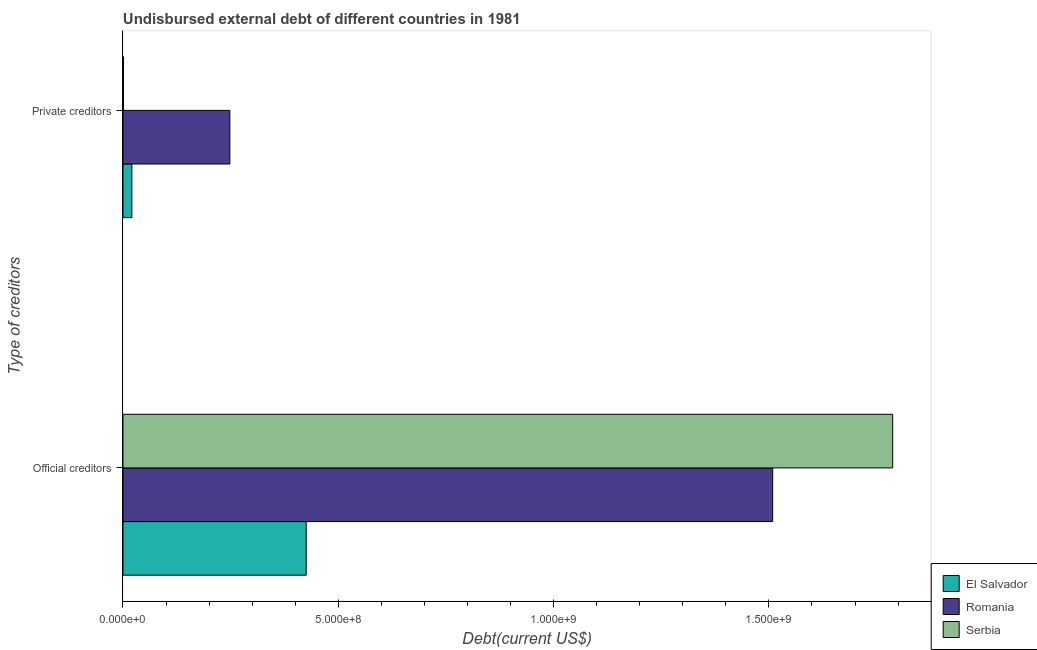How many different coloured bars are there?
Your response must be concise. 3. Are the number of bars on each tick of the Y-axis equal?
Give a very brief answer. Yes. How many bars are there on the 2nd tick from the bottom?
Keep it short and to the point. 3. What is the label of the 1st group of bars from the top?
Offer a very short reply. Private creditors. What is the undisbursed external debt of private creditors in El Salvador?
Your answer should be very brief. 2.06e+07. Across all countries, what is the maximum undisbursed external debt of official creditors?
Provide a short and direct response. 1.79e+09. Across all countries, what is the minimum undisbursed external debt of official creditors?
Keep it short and to the point. 4.26e+08. In which country was the undisbursed external debt of private creditors maximum?
Ensure brevity in your answer.  Romania. In which country was the undisbursed external debt of official creditors minimum?
Your answer should be very brief. El Salvador. What is the total undisbursed external debt of private creditors in the graph?
Provide a short and direct response. 2.70e+08. What is the difference between the undisbursed external debt of official creditors in Serbia and that in El Salvador?
Keep it short and to the point. 1.36e+09. What is the difference between the undisbursed external debt of official creditors in Romania and the undisbursed external debt of private creditors in El Salvador?
Your answer should be compact. 1.49e+09. What is the average undisbursed external debt of official creditors per country?
Your answer should be very brief. 1.24e+09. What is the difference between the undisbursed external debt of private creditors and undisbursed external debt of official creditors in Serbia?
Provide a succinct answer. -1.79e+09. What is the ratio of the undisbursed external debt of private creditors in Serbia to that in El Salvador?
Provide a short and direct response. 0.06. What does the 3rd bar from the top in Official creditors represents?
Give a very brief answer. El Salvador. What does the 2nd bar from the bottom in Private creditors represents?
Make the answer very short. Romania. How many bars are there?
Offer a terse response. 6. Are all the bars in the graph horizontal?
Provide a succinct answer. Yes. How many countries are there in the graph?
Provide a succinct answer. 3. Does the graph contain any zero values?
Your response must be concise. No. How many legend labels are there?
Your answer should be compact. 3. What is the title of the graph?
Your response must be concise. Undisbursed external debt of different countries in 1981. Does "Euro area" appear as one of the legend labels in the graph?
Give a very brief answer. No. What is the label or title of the X-axis?
Your answer should be very brief. Debt(current US$). What is the label or title of the Y-axis?
Give a very brief answer. Type of creditors. What is the Debt(current US$) of El Salvador in Official creditors?
Provide a short and direct response. 4.26e+08. What is the Debt(current US$) in Romania in Official creditors?
Ensure brevity in your answer.  1.51e+09. What is the Debt(current US$) of Serbia in Official creditors?
Give a very brief answer. 1.79e+09. What is the Debt(current US$) in El Salvador in Private creditors?
Make the answer very short. 2.06e+07. What is the Debt(current US$) of Romania in Private creditors?
Offer a very short reply. 2.48e+08. What is the Debt(current US$) of Serbia in Private creditors?
Your response must be concise. 1.14e+06. Across all Type of creditors, what is the maximum Debt(current US$) of El Salvador?
Your answer should be compact. 4.26e+08. Across all Type of creditors, what is the maximum Debt(current US$) in Romania?
Give a very brief answer. 1.51e+09. Across all Type of creditors, what is the maximum Debt(current US$) of Serbia?
Provide a succinct answer. 1.79e+09. Across all Type of creditors, what is the minimum Debt(current US$) of El Salvador?
Give a very brief answer. 2.06e+07. Across all Type of creditors, what is the minimum Debt(current US$) in Romania?
Your answer should be very brief. 2.48e+08. Across all Type of creditors, what is the minimum Debt(current US$) in Serbia?
Your response must be concise. 1.14e+06. What is the total Debt(current US$) of El Salvador in the graph?
Offer a very short reply. 4.46e+08. What is the total Debt(current US$) of Romania in the graph?
Offer a terse response. 1.76e+09. What is the total Debt(current US$) of Serbia in the graph?
Your response must be concise. 1.79e+09. What is the difference between the Debt(current US$) of El Salvador in Official creditors and that in Private creditors?
Give a very brief answer. 4.05e+08. What is the difference between the Debt(current US$) of Romania in Official creditors and that in Private creditors?
Your answer should be very brief. 1.26e+09. What is the difference between the Debt(current US$) in Serbia in Official creditors and that in Private creditors?
Make the answer very short. 1.79e+09. What is the difference between the Debt(current US$) of El Salvador in Official creditors and the Debt(current US$) of Romania in Private creditors?
Offer a terse response. 1.77e+08. What is the difference between the Debt(current US$) in El Salvador in Official creditors and the Debt(current US$) in Serbia in Private creditors?
Make the answer very short. 4.24e+08. What is the difference between the Debt(current US$) in Romania in Official creditors and the Debt(current US$) in Serbia in Private creditors?
Offer a very short reply. 1.51e+09. What is the average Debt(current US$) of El Salvador per Type of creditors?
Provide a succinct answer. 2.23e+08. What is the average Debt(current US$) of Romania per Type of creditors?
Offer a very short reply. 8.78e+08. What is the average Debt(current US$) in Serbia per Type of creditors?
Offer a terse response. 8.94e+08. What is the difference between the Debt(current US$) of El Salvador and Debt(current US$) of Romania in Official creditors?
Your response must be concise. -1.08e+09. What is the difference between the Debt(current US$) in El Salvador and Debt(current US$) in Serbia in Official creditors?
Offer a terse response. -1.36e+09. What is the difference between the Debt(current US$) of Romania and Debt(current US$) of Serbia in Official creditors?
Provide a succinct answer. -2.79e+08. What is the difference between the Debt(current US$) in El Salvador and Debt(current US$) in Romania in Private creditors?
Ensure brevity in your answer.  -2.28e+08. What is the difference between the Debt(current US$) in El Salvador and Debt(current US$) in Serbia in Private creditors?
Offer a terse response. 1.95e+07. What is the difference between the Debt(current US$) in Romania and Debt(current US$) in Serbia in Private creditors?
Your answer should be very brief. 2.47e+08. What is the ratio of the Debt(current US$) in El Salvador in Official creditors to that in Private creditors?
Your answer should be compact. 20.64. What is the ratio of the Debt(current US$) of Romania in Official creditors to that in Private creditors?
Your answer should be very brief. 6.08. What is the ratio of the Debt(current US$) of Serbia in Official creditors to that in Private creditors?
Offer a very short reply. 1563.79. What is the difference between the highest and the second highest Debt(current US$) of El Salvador?
Ensure brevity in your answer.  4.05e+08. What is the difference between the highest and the second highest Debt(current US$) of Romania?
Provide a succinct answer. 1.26e+09. What is the difference between the highest and the second highest Debt(current US$) in Serbia?
Offer a very short reply. 1.79e+09. What is the difference between the highest and the lowest Debt(current US$) in El Salvador?
Keep it short and to the point. 4.05e+08. What is the difference between the highest and the lowest Debt(current US$) in Romania?
Provide a succinct answer. 1.26e+09. What is the difference between the highest and the lowest Debt(current US$) in Serbia?
Your response must be concise. 1.79e+09. 